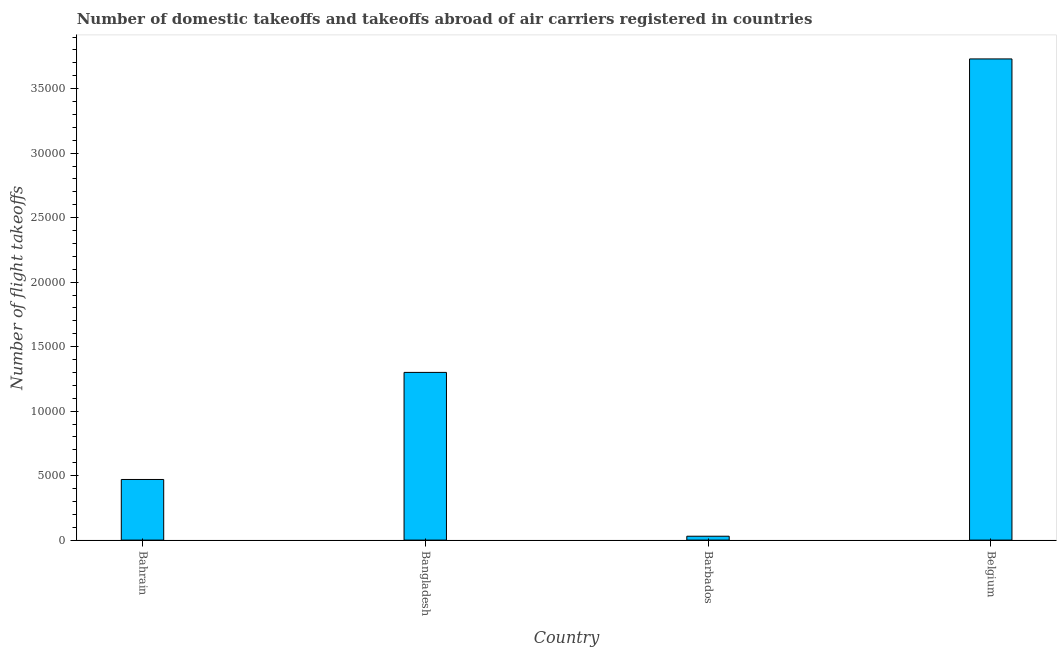Does the graph contain any zero values?
Offer a very short reply. No. Does the graph contain grids?
Provide a succinct answer. No. What is the title of the graph?
Give a very brief answer. Number of domestic takeoffs and takeoffs abroad of air carriers registered in countries. What is the label or title of the Y-axis?
Ensure brevity in your answer.  Number of flight takeoffs. What is the number of flight takeoffs in Belgium?
Your answer should be very brief. 3.73e+04. Across all countries, what is the maximum number of flight takeoffs?
Ensure brevity in your answer.  3.73e+04. Across all countries, what is the minimum number of flight takeoffs?
Your response must be concise. 300. In which country was the number of flight takeoffs maximum?
Keep it short and to the point. Belgium. In which country was the number of flight takeoffs minimum?
Your response must be concise. Barbados. What is the sum of the number of flight takeoffs?
Ensure brevity in your answer.  5.53e+04. What is the difference between the number of flight takeoffs in Bangladesh and Belgium?
Offer a terse response. -2.43e+04. What is the average number of flight takeoffs per country?
Provide a succinct answer. 1.38e+04. What is the median number of flight takeoffs?
Offer a terse response. 8850. In how many countries, is the number of flight takeoffs greater than 8000 ?
Offer a terse response. 2. What is the ratio of the number of flight takeoffs in Bahrain to that in Belgium?
Your response must be concise. 0.13. What is the difference between the highest and the second highest number of flight takeoffs?
Provide a short and direct response. 2.43e+04. Is the sum of the number of flight takeoffs in Bahrain and Bangladesh greater than the maximum number of flight takeoffs across all countries?
Keep it short and to the point. No. What is the difference between the highest and the lowest number of flight takeoffs?
Provide a short and direct response. 3.70e+04. Are all the bars in the graph horizontal?
Keep it short and to the point. No. How many countries are there in the graph?
Ensure brevity in your answer.  4. Are the values on the major ticks of Y-axis written in scientific E-notation?
Provide a succinct answer. No. What is the Number of flight takeoffs of Bahrain?
Offer a very short reply. 4700. What is the Number of flight takeoffs in Bangladesh?
Ensure brevity in your answer.  1.30e+04. What is the Number of flight takeoffs in Barbados?
Keep it short and to the point. 300. What is the Number of flight takeoffs in Belgium?
Offer a terse response. 3.73e+04. What is the difference between the Number of flight takeoffs in Bahrain and Bangladesh?
Your response must be concise. -8300. What is the difference between the Number of flight takeoffs in Bahrain and Barbados?
Offer a terse response. 4400. What is the difference between the Number of flight takeoffs in Bahrain and Belgium?
Give a very brief answer. -3.26e+04. What is the difference between the Number of flight takeoffs in Bangladesh and Barbados?
Your response must be concise. 1.27e+04. What is the difference between the Number of flight takeoffs in Bangladesh and Belgium?
Your answer should be compact. -2.43e+04. What is the difference between the Number of flight takeoffs in Barbados and Belgium?
Your answer should be compact. -3.70e+04. What is the ratio of the Number of flight takeoffs in Bahrain to that in Bangladesh?
Provide a short and direct response. 0.36. What is the ratio of the Number of flight takeoffs in Bahrain to that in Barbados?
Provide a short and direct response. 15.67. What is the ratio of the Number of flight takeoffs in Bahrain to that in Belgium?
Ensure brevity in your answer.  0.13. What is the ratio of the Number of flight takeoffs in Bangladesh to that in Barbados?
Provide a short and direct response. 43.33. What is the ratio of the Number of flight takeoffs in Bangladesh to that in Belgium?
Keep it short and to the point. 0.35. What is the ratio of the Number of flight takeoffs in Barbados to that in Belgium?
Make the answer very short. 0.01. 